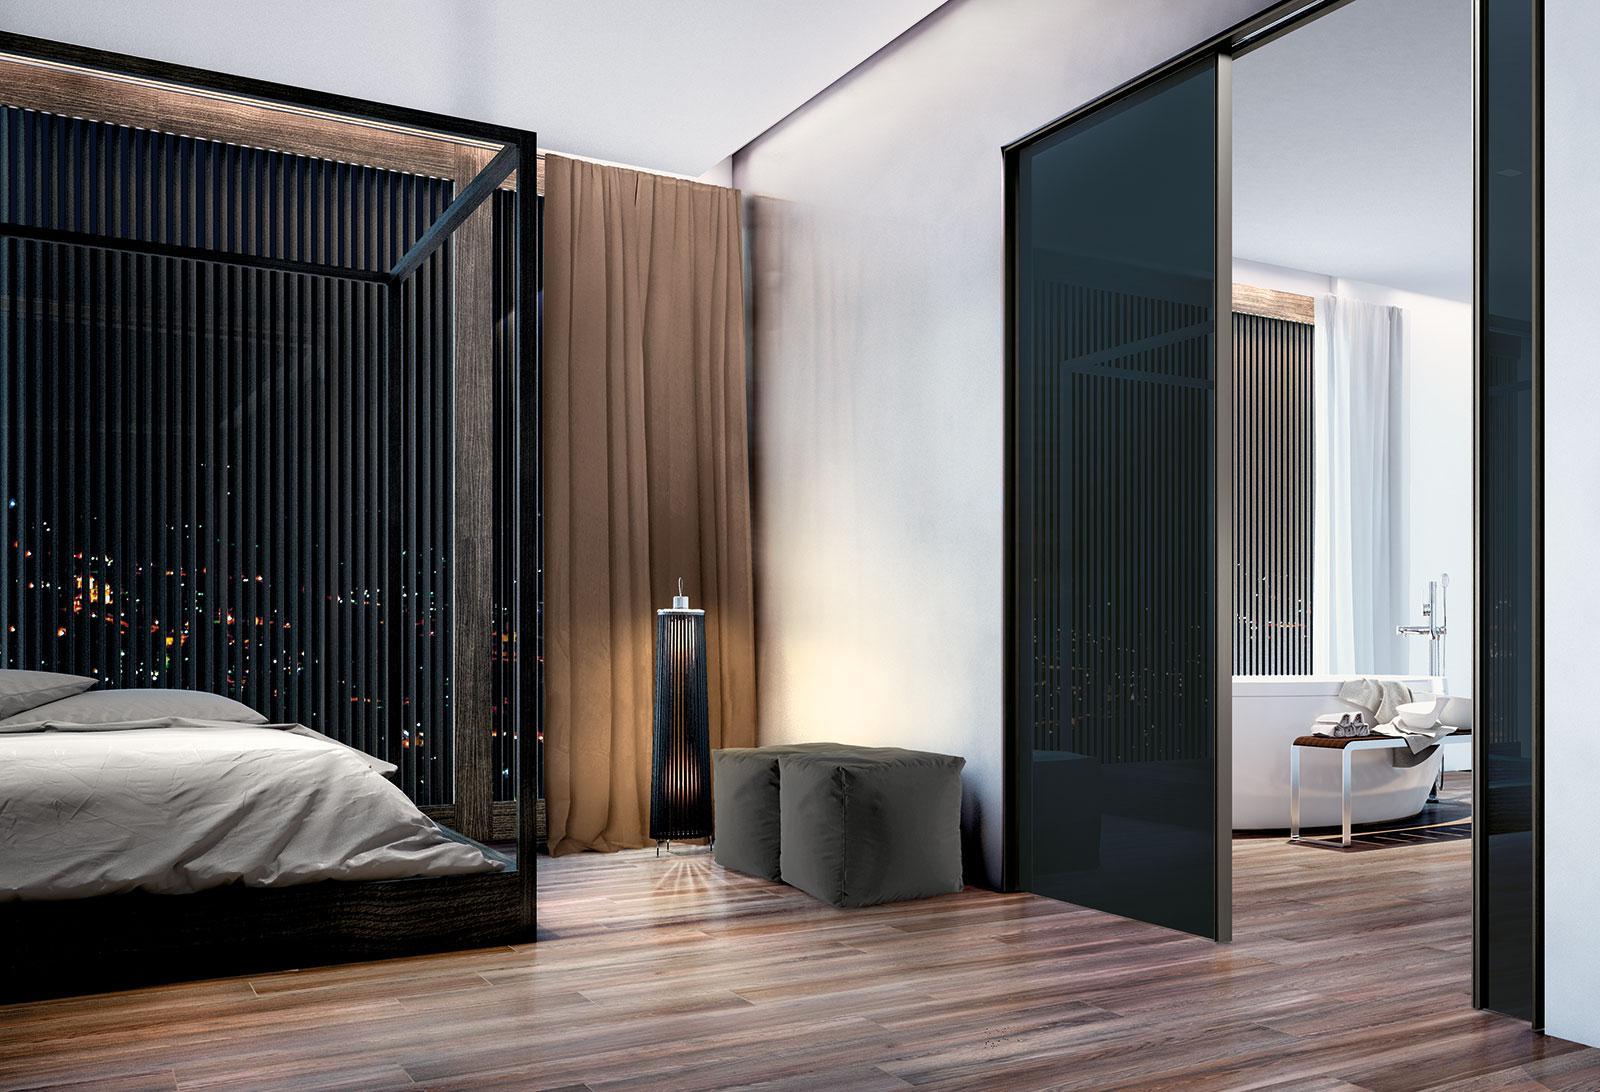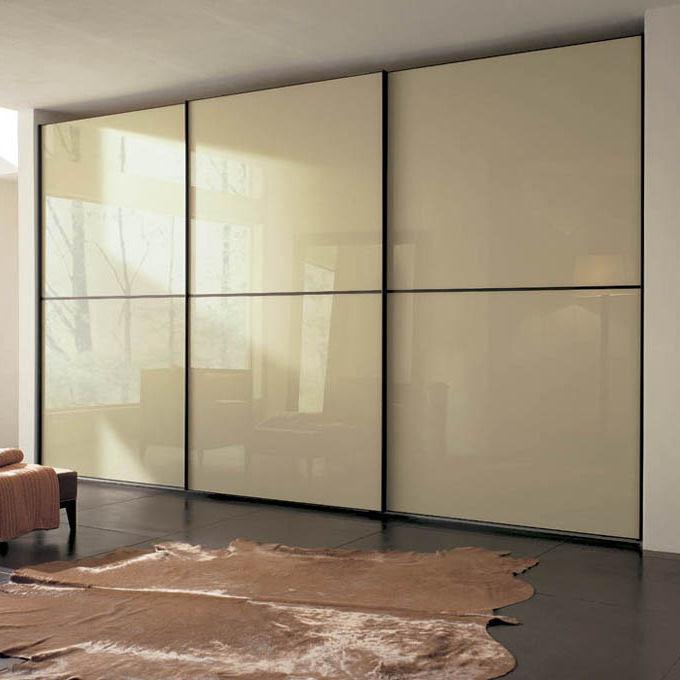The first image is the image on the left, the second image is the image on the right. Evaluate the accuracy of this statement regarding the images: "The left and right image contains the same number of closed closet doors.". Is it true? Answer yes or no. No. The first image is the image on the left, the second image is the image on the right. Examine the images to the left and right. Is the description "The right image shows at least three earth-tone sliding doors with no embellishments." accurate? Answer yes or no. Yes. 